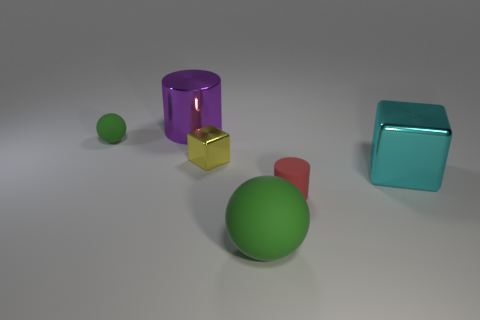Is there a rubber thing that has the same color as the large matte sphere?
Ensure brevity in your answer.  Yes. Does the green thing that is behind the big cyan metal cube have the same material as the object right of the rubber cylinder?
Your response must be concise. No. How big is the purple metal cylinder that is on the left side of the cyan cube?
Offer a terse response. Large. The yellow metal cube has what size?
Your response must be concise. Small. What is the size of the green ball that is behind the green rubber thing right of the green object behind the large cyan object?
Make the answer very short. Small. Are there any gray spheres made of the same material as the tiny red cylinder?
Your response must be concise. No. What is the shape of the big purple thing?
Offer a very short reply. Cylinder. The cylinder that is the same material as the big green sphere is what color?
Your answer should be very brief. Red. How many purple objects are either small matte things or big metallic cylinders?
Provide a succinct answer. 1. Is the number of red matte cylinders greater than the number of large brown metal things?
Offer a very short reply. Yes. 